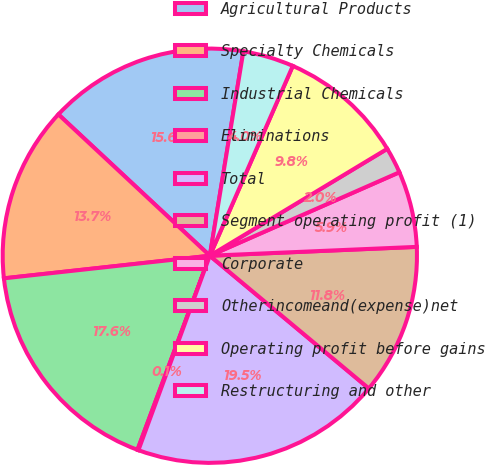<chart> <loc_0><loc_0><loc_500><loc_500><pie_chart><fcel>Agricultural Products<fcel>Specialty Chemicals<fcel>Industrial Chemicals<fcel>Eliminations<fcel>Total<fcel>Segment operating profit (1)<fcel>Corporate<fcel>Otherincomeand(expense)net<fcel>Operating profit before gains<fcel>Restructuring and other<nl><fcel>15.64%<fcel>13.69%<fcel>17.58%<fcel>0.08%<fcel>19.53%<fcel>11.75%<fcel>5.92%<fcel>2.03%<fcel>9.81%<fcel>3.97%<nl></chart> 